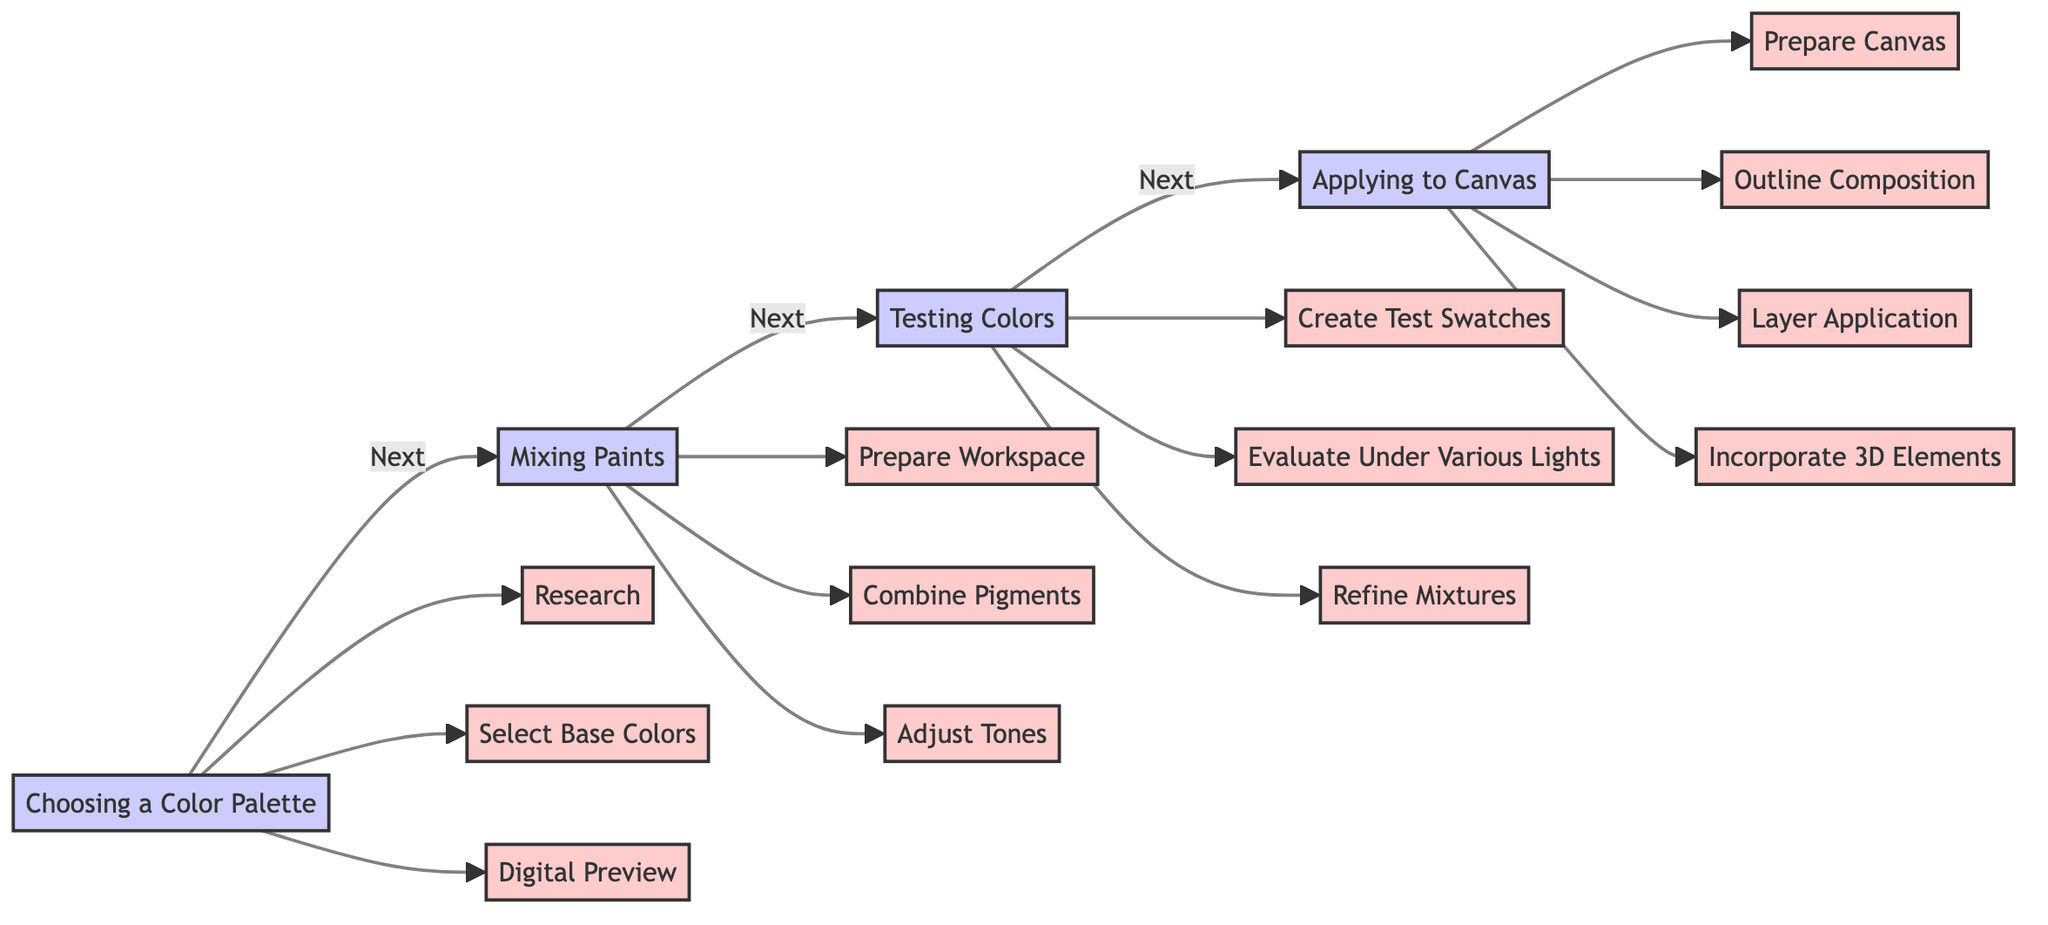What is the first step in the process? The first step labeled in the diagram is "Choosing a Color Palette."
Answer: Choosing a Color Palette How many actions are there in the "Mixing Paints" step? The "Mixing Paints" step includes three actions: "Prepare Workspace," "Combine Pigments," and "Adjust Tones."
Answer: 3 What follows the "Testing Colors" step? The diagram indicates that "Applying to Canvas" is the next step that follows "Testing Colors."
Answer: Applying to Canvas Which action involves evaluating colors under different lighting? The action "Evaluate Under Various Lights" pertains to observing how colors behave in different lighting conditions.
Answer: Evaluate Under Various Lights What is the last action listed in the "Applying to Canvas" step? The last action in the "Applying to Canvas" section is "Incorporate 3D Elements."
Answer: Incorporate 3D Elements How many total steps are there in the flowchart? The flowchart consists of four main steps: "Choosing a Color Palette," "Mixing Paints," "Testing Colors," and "Applying to Canvas," totaling four steps.
Answer: 4 Which step includes the action of creating test swatches? The action "Create Test Swatches" is part of the "Testing Colors" step in the process.
Answer: Testing Colors Which two steps are directly connected without any actions in-between? The steps "Mixing Paints" and "Testing Colors" are directly connected, as there are no intervening steps between them.
Answer: Mixing Paints and Testing Colors What is the relationship between "Select Base Colors" and the "Choosing a Color Palette" step? "Select Base Colors" is an action under the "Choosing a Color Palette" step, indicating that it is part of that phase.
Answer: Select Base Colors 